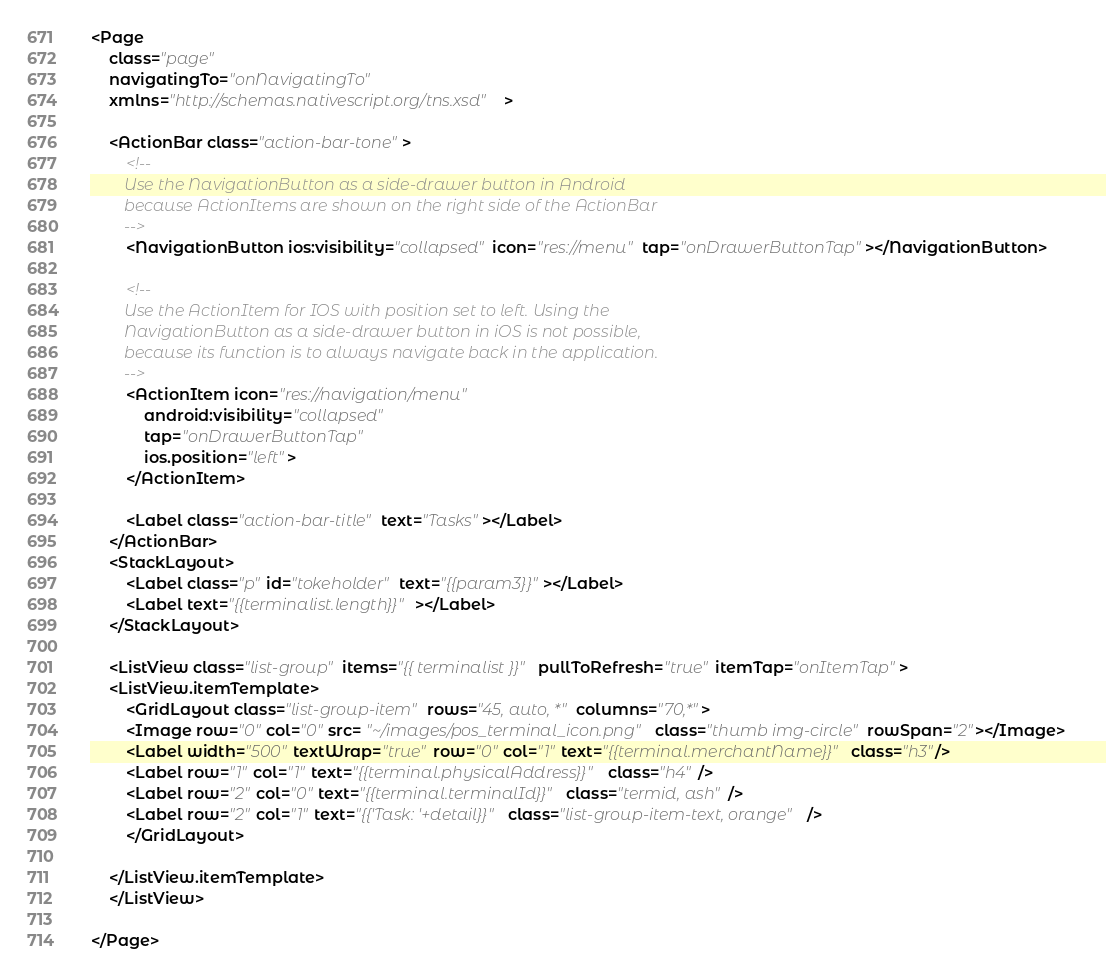<code> <loc_0><loc_0><loc_500><loc_500><_XML_><Page
    class="page"
    navigatingTo="onNavigatingTo"  
    xmlns="http://schemas.nativescript.org/tns.xsd">

    <ActionBar class="action-bar-tone">
        <!-- 
        Use the NavigationButton as a side-drawer button in Android
        because ActionItems are shown on the right side of the ActionBar
        -->
        <NavigationButton ios:visibility="collapsed" icon="res://menu" tap="onDrawerButtonTap"></NavigationButton>       

        <!-- 
        Use the ActionItem for IOS with position set to left. Using the
        NavigationButton as a side-drawer button in iOS is not possible,
        because its function is to always navigate back in the application.
        -->
        <ActionItem icon="res://navigation/menu" 
            android:visibility="collapsed" 
            tap="onDrawerButtonTap"
            ios.position="left">
        </ActionItem>
        
        <Label class="action-bar-title" text="Tasks"></Label>
    </ActionBar>    
    <StackLayout>             
        <Label class="p" id="tokeholder" text="{{param3}}"></Label>  
        <Label text="{{terminalist.length}}"></Label>  
    </StackLayout>

    <ListView class="list-group" items="{{ terminalist }}" pullToRefresh="true" itemTap="onItemTap">
    <ListView.itemTemplate>
        <GridLayout class="list-group-item" rows="45, auto, *" columns="70,*">
        <Image row="0" col="0" src= "~/images/pos_terminal_icon.png" class="thumb img-circle" rowSpan="2"></Image>
        <Label width="500" textWrap="true" row="0" col="1" text="{{terminal.merchantName}}" class="h3"/>
        <Label row="1" col="1" text="{{terminal.physicalAddress}}" class="h4" />
        <Label row="2" col="0" text="{{terminal.terminalId}}" class="termid, ash" />
        <Label row="2" col="1" text="{{'Task: '+detail}}" class="list-group-item-text, orange" />        
        </GridLayout>
        
    </ListView.itemTemplate>       
    </ListView>       
          
</Page>
</code> 